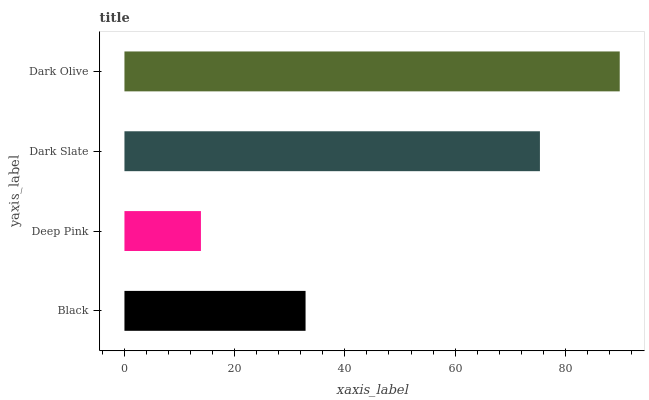Is Deep Pink the minimum?
Answer yes or no. Yes. Is Dark Olive the maximum?
Answer yes or no. Yes. Is Dark Slate the minimum?
Answer yes or no. No. Is Dark Slate the maximum?
Answer yes or no. No. Is Dark Slate greater than Deep Pink?
Answer yes or no. Yes. Is Deep Pink less than Dark Slate?
Answer yes or no. Yes. Is Deep Pink greater than Dark Slate?
Answer yes or no. No. Is Dark Slate less than Deep Pink?
Answer yes or no. No. Is Dark Slate the high median?
Answer yes or no. Yes. Is Black the low median?
Answer yes or no. Yes. Is Deep Pink the high median?
Answer yes or no. No. Is Dark Olive the low median?
Answer yes or no. No. 